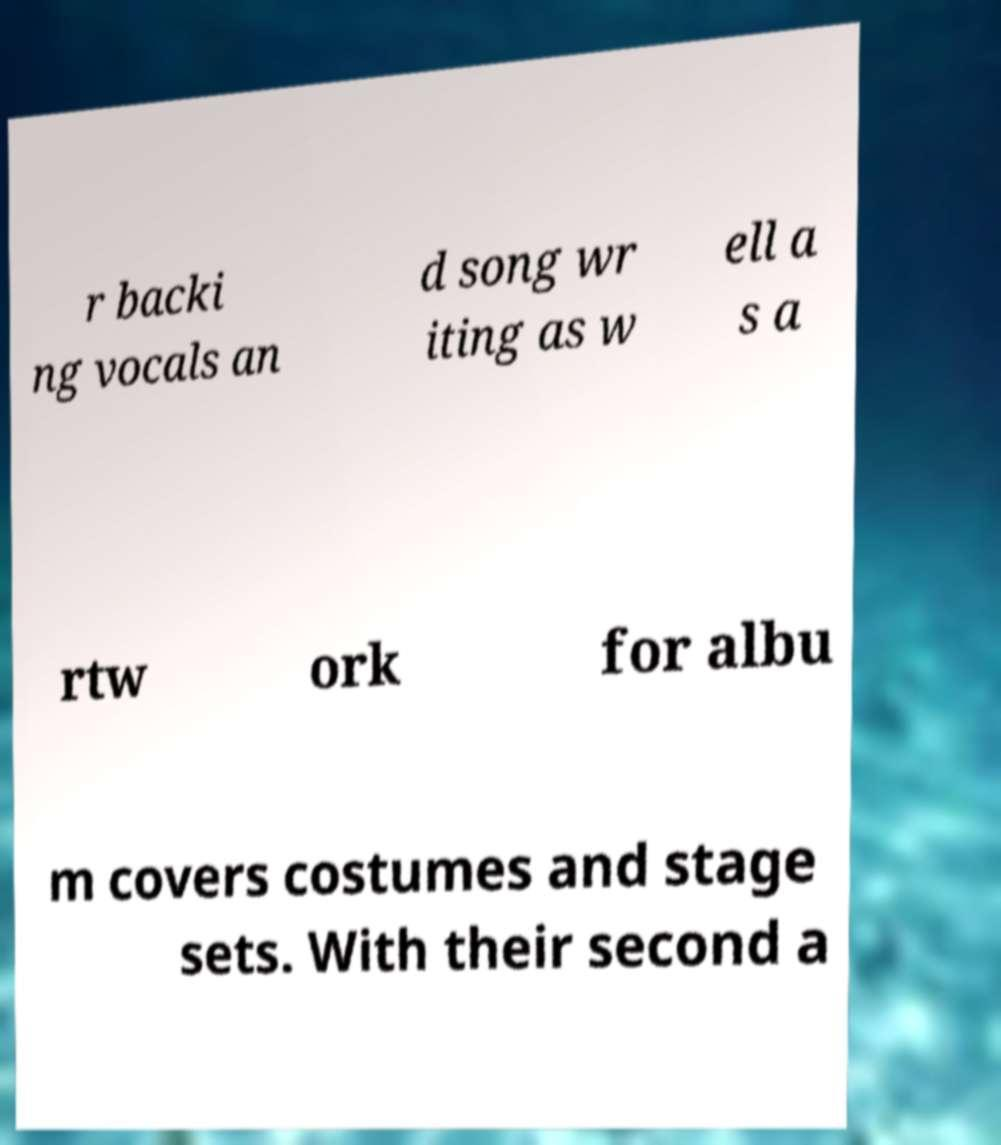Can you accurately transcribe the text from the provided image for me? r backi ng vocals an d song wr iting as w ell a s a rtw ork for albu m covers costumes and stage sets. With their second a 